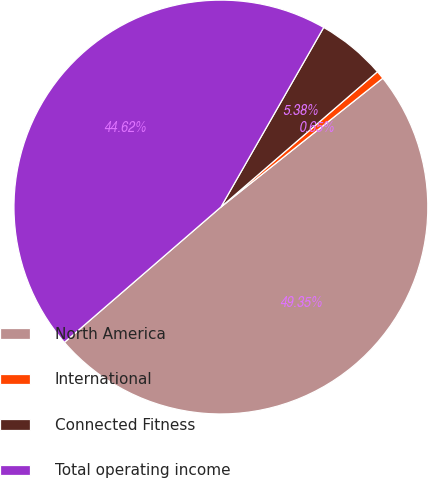<chart> <loc_0><loc_0><loc_500><loc_500><pie_chart><fcel>North America<fcel>International<fcel>Connected Fitness<fcel>Total operating income<nl><fcel>49.35%<fcel>0.65%<fcel>5.38%<fcel>44.62%<nl></chart> 